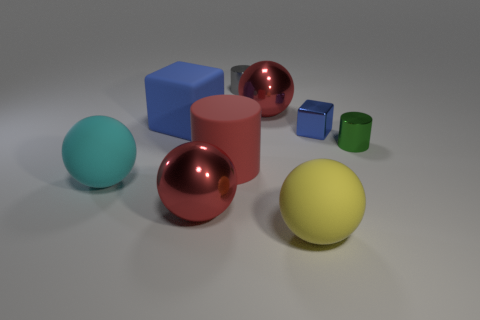Subtract all gray cylinders. How many red spheres are left? 2 Subtract all big cyan spheres. How many spheres are left? 3 Subtract all yellow balls. How many balls are left? 3 Subtract 2 balls. How many balls are left? 2 Subtract all cyan balls. Subtract all red cylinders. How many balls are left? 3 Add 1 big red things. How many objects exist? 10 Subtract all spheres. How many objects are left? 5 Subtract all large matte cubes. Subtract all tiny gray cylinders. How many objects are left? 7 Add 3 yellow spheres. How many yellow spheres are left? 4 Add 6 tiny cubes. How many tiny cubes exist? 7 